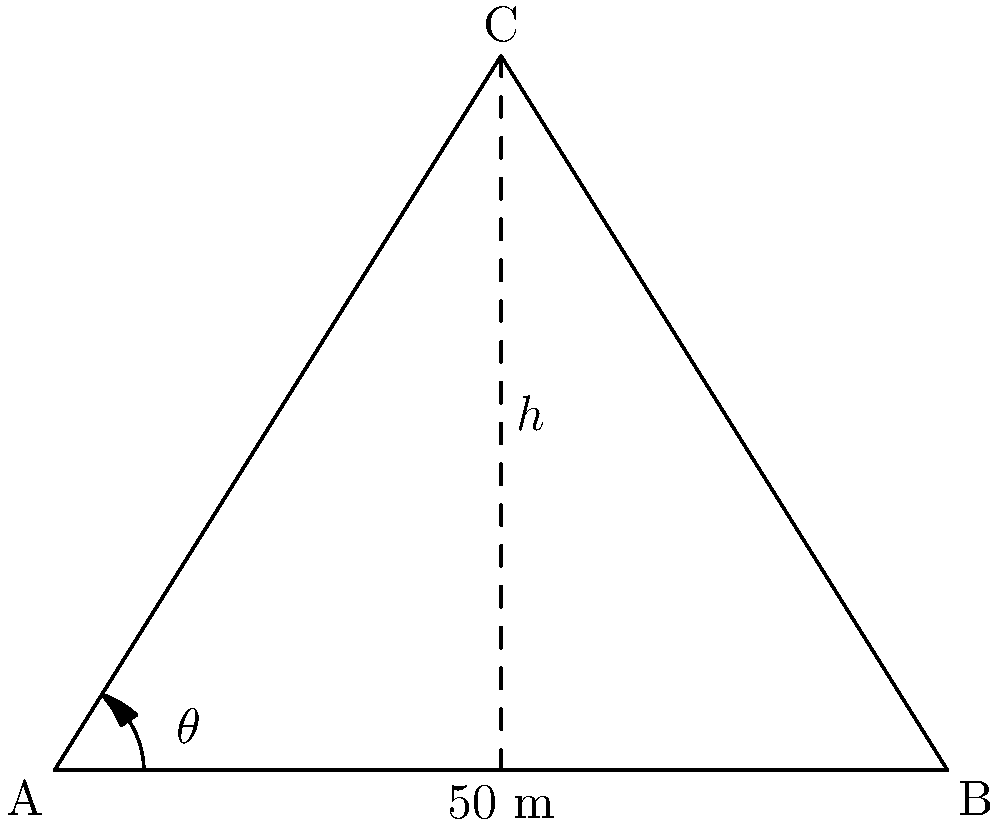A digital billboard is to be installed on top of a building. The optimal viewing angle $\theta$ is crucial for maximum visibility from street level. If the billboard is 50 meters away from the viewing point and has a height of 8 meters above street level, what is the optimal viewing angle $\theta$ in degrees? To solve this problem, we'll use the tangent trigonometric ratio. Let's approach this step-by-step:

1) In the right-angled triangle formed, we know:
   - The adjacent side (distance from viewing point to billboard) = 50 meters
   - The opposite side (height of billboard) = 8 meters

2) The tangent of an angle is defined as the ratio of the opposite side to the adjacent side:

   $\tan \theta = \frac{\text{opposite}}{\text{adjacent}}$

3) Substituting our known values:

   $\tan \theta = \frac{8}{50}$

4) To find $\theta$, we need to use the inverse tangent (arctan or $\tan^{-1}$):

   $\theta = \tan^{-1}(\frac{8}{50})$

5) Using a calculator or computing software:

   $\theta \approx 9.09$ degrees

Therefore, the optimal viewing angle is approximately 9.09 degrees.
Answer: $9.09°$ 